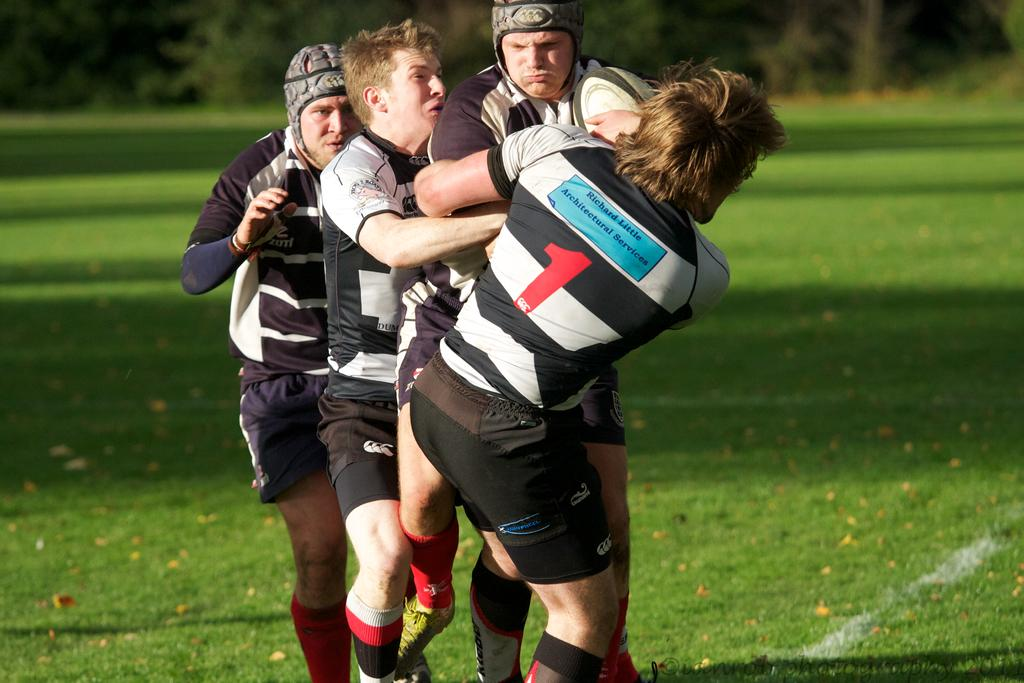How many people are in the image? There are four persons in the image. What are the persons doing in the image? The persons are standing and fighting for a ball. Where does the scene take place? The scene takes place on a ground. What type of engine can be seen in the image? There is no engine present in the image; it features four persons standing and fighting for a ball. What is the reason for the protest in the image? There is no protest depicted in the image; it shows a scene of people fighting for a ball. 